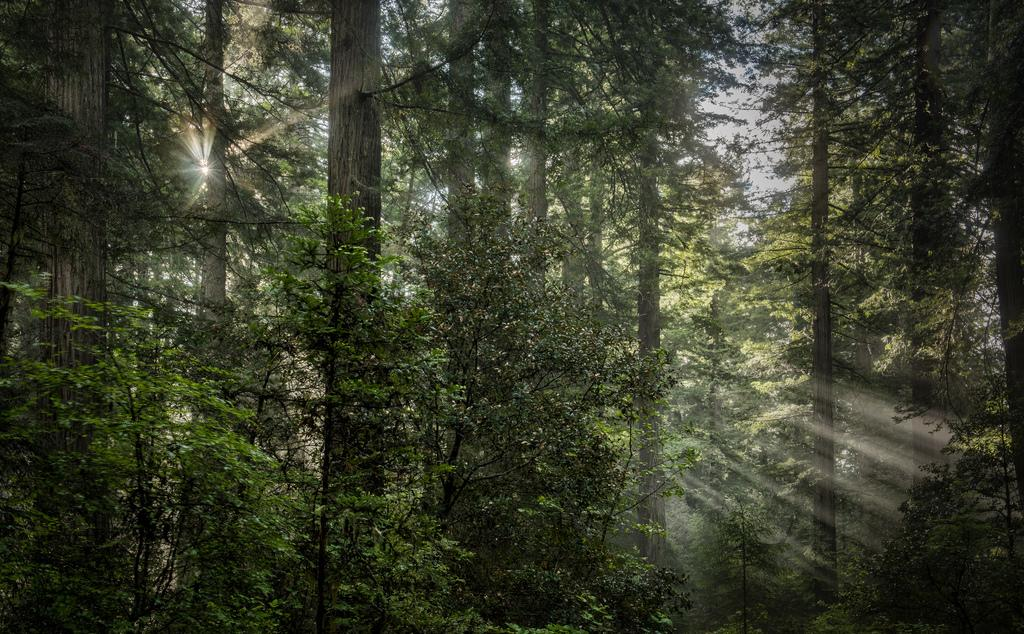What type of vegetation can be seen in the image? There are trees in the image. Can you describe the trees in the image? The facts provided do not give specific details about the trees, so we cannot describe them further. What might be the purpose of the trees in the image? The trees in the image could serve various purposes, such as providing shade, habitat for wildlife, or aesthetic value. However, without additional context, we cannot determine their specific purpose. What type of watch is the tree wearing in the image? There is no watch present in the image, as the subject is trees, which are inanimate objects and do not wear watches. 